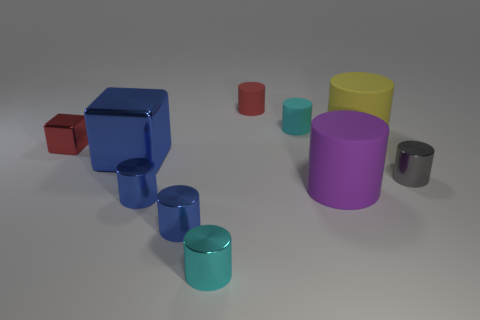What is the material of the yellow cylinder that is the same size as the purple cylinder?
Offer a terse response. Rubber. What material is the cylinder that is right of the small red rubber cylinder and behind the yellow rubber object?
Keep it short and to the point. Rubber. Is the material of the small cylinder on the right side of the cyan matte cylinder the same as the tiny cyan cylinder in front of the big yellow cylinder?
Your answer should be very brief. Yes. There is a red thing in front of the big matte cylinder behind the tiny red object that is left of the small red matte object; what is its size?
Offer a terse response. Small. What number of gray things have the same material as the purple object?
Your answer should be compact. 0. Is the number of tiny shiny cylinders less than the number of red metal things?
Offer a very short reply. No. What size is the purple thing that is the same shape as the yellow thing?
Your response must be concise. Large. Does the tiny cyan cylinder behind the cyan metallic thing have the same material as the red cylinder?
Your answer should be compact. Yes. Is the big yellow rubber object the same shape as the small red metal thing?
Your answer should be very brief. No. How many objects are tiny metallic things on the right side of the large shiny block or large gray things?
Your response must be concise. 4. 